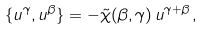<formula> <loc_0><loc_0><loc_500><loc_500>\{ u ^ { \gamma } , u ^ { \beta } \} = - \tilde { \chi } ( \beta , \gamma ) \, u ^ { \gamma + \beta } \, ,</formula> 